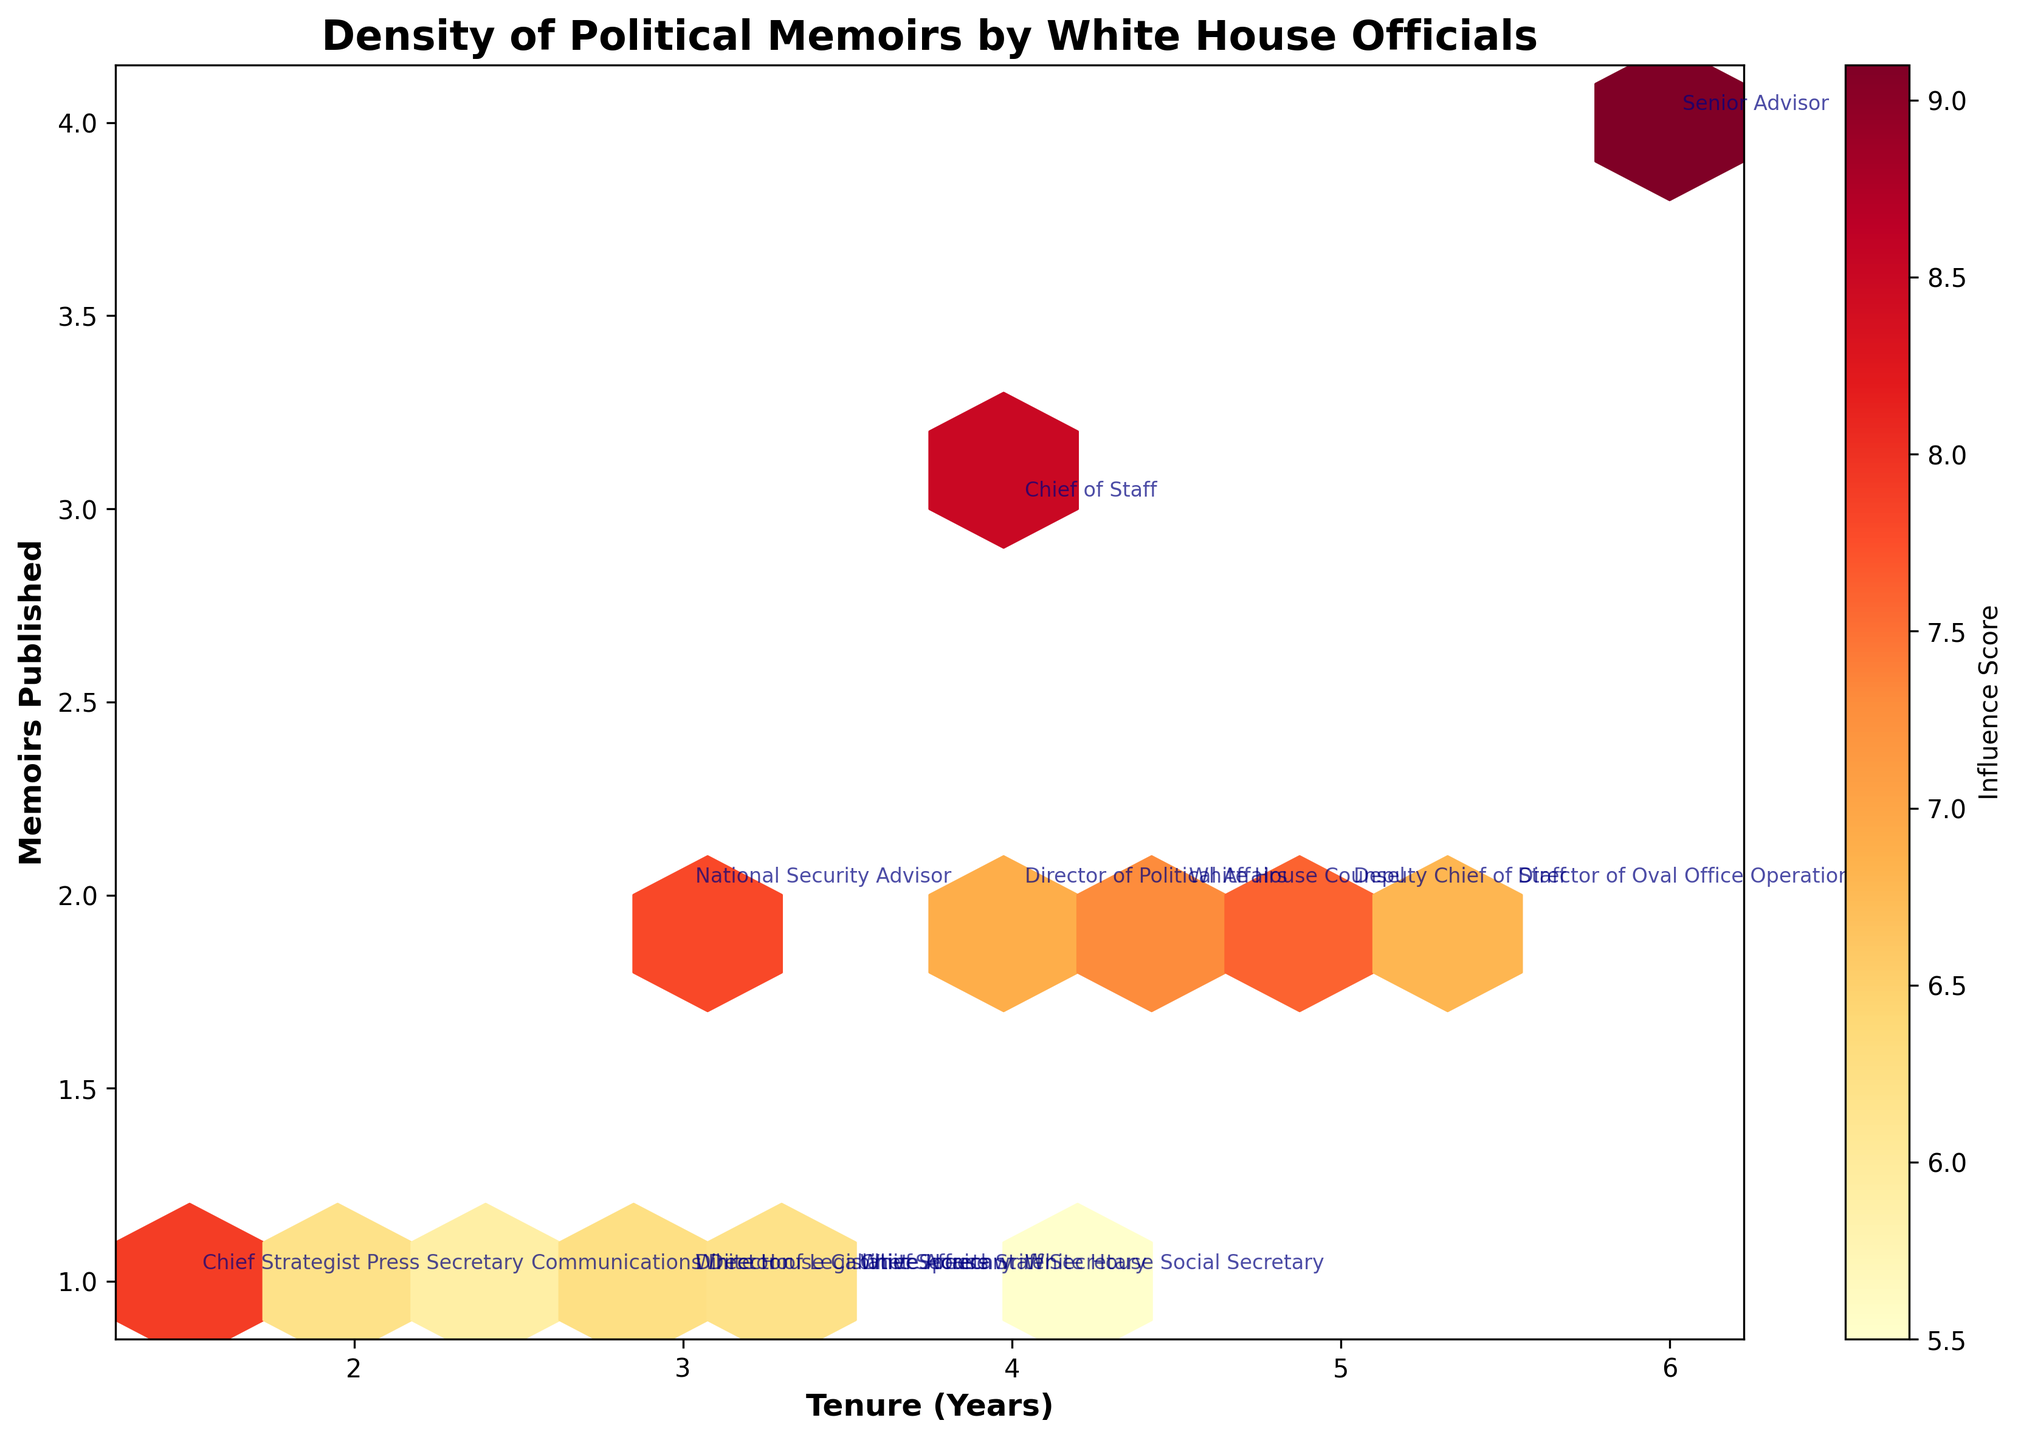What is the title of the plot? The title of the plot is usually found at the top of the figure, and it describes the overall content of the graph.
Answer: Density of Political Memoirs by White House Officials What does the color scale represent in the plot? In a Hexbin plot with a color scale, the color intensity usually represents a third variable. Here, the color scale label 'Influence Score' suggests that it shows the Influence Score of the individuals.
Answer: Influence Score Which role has published the most memoirs? By looking at the y-axis labeled 'Memoirs Published' and the annotations near the highest points, we can see which role is associated with the highest number of memoirs published.
Answer: Senior Advisor How many memoirs did the 'Chief of Staff' publish? By finding the 'Chief of Staff' annotation on the plot, and looking at its corresponding y-coordinate on the 'Memoirs Published' axis, we can determine the number of memoirs published.
Answer: 3 Among the 'Chief of Staff' and 'Press Secretary', who had higher influence scores? By locating the 'Chief of Staff' and 'Press Secretary' on the plot and checking the color intensity per the color scale, we can compare their Influence Scores.
Answer: Chief of Staff For roles with a tenure of 3 years, how many memoirs were typically published? By focusing on the x-axis (Tenure) at the point 3, and observing the y-coordinates around that point, we can see how many memoirs were published for each role at that tenure.
Answer: 1-2 What's the range of 'Influence Scores' shown in the colorbar? By looking at the colorbar on the right side of the plot, one can read off the numerical values at both ends of the bar to understand the range.
Answer: 5.5 to 9.1 Which role had the shortest tenure and how many memoirs did they publish? Locate the annotation 'Chief Strategist' on the plot, and check its x-coordinate on the 'Tenure (Years)' axis and the y-coordinate on the 'Memoirs Published' axis.
Answer: Chief Strategist; 1 memoir What is the relationship between tenure and the number of memoirs published in general? By observing the plot as a whole, look for overall trends or patterns in how 'Tenure (Years)' on the x-axis relates to 'Memoirs Published' on the y-axis.
Answer: Roles with longer tenures tend to publish more memoirs Which role with exactly 2 published memoirs had the highest influence score, and what was the score? Locate the annotations at the level of 2 memoirs on the y-axis, and compare their color intensities according to the color scale to find the highest score.
Answer: Senior Advisor; 9.1 